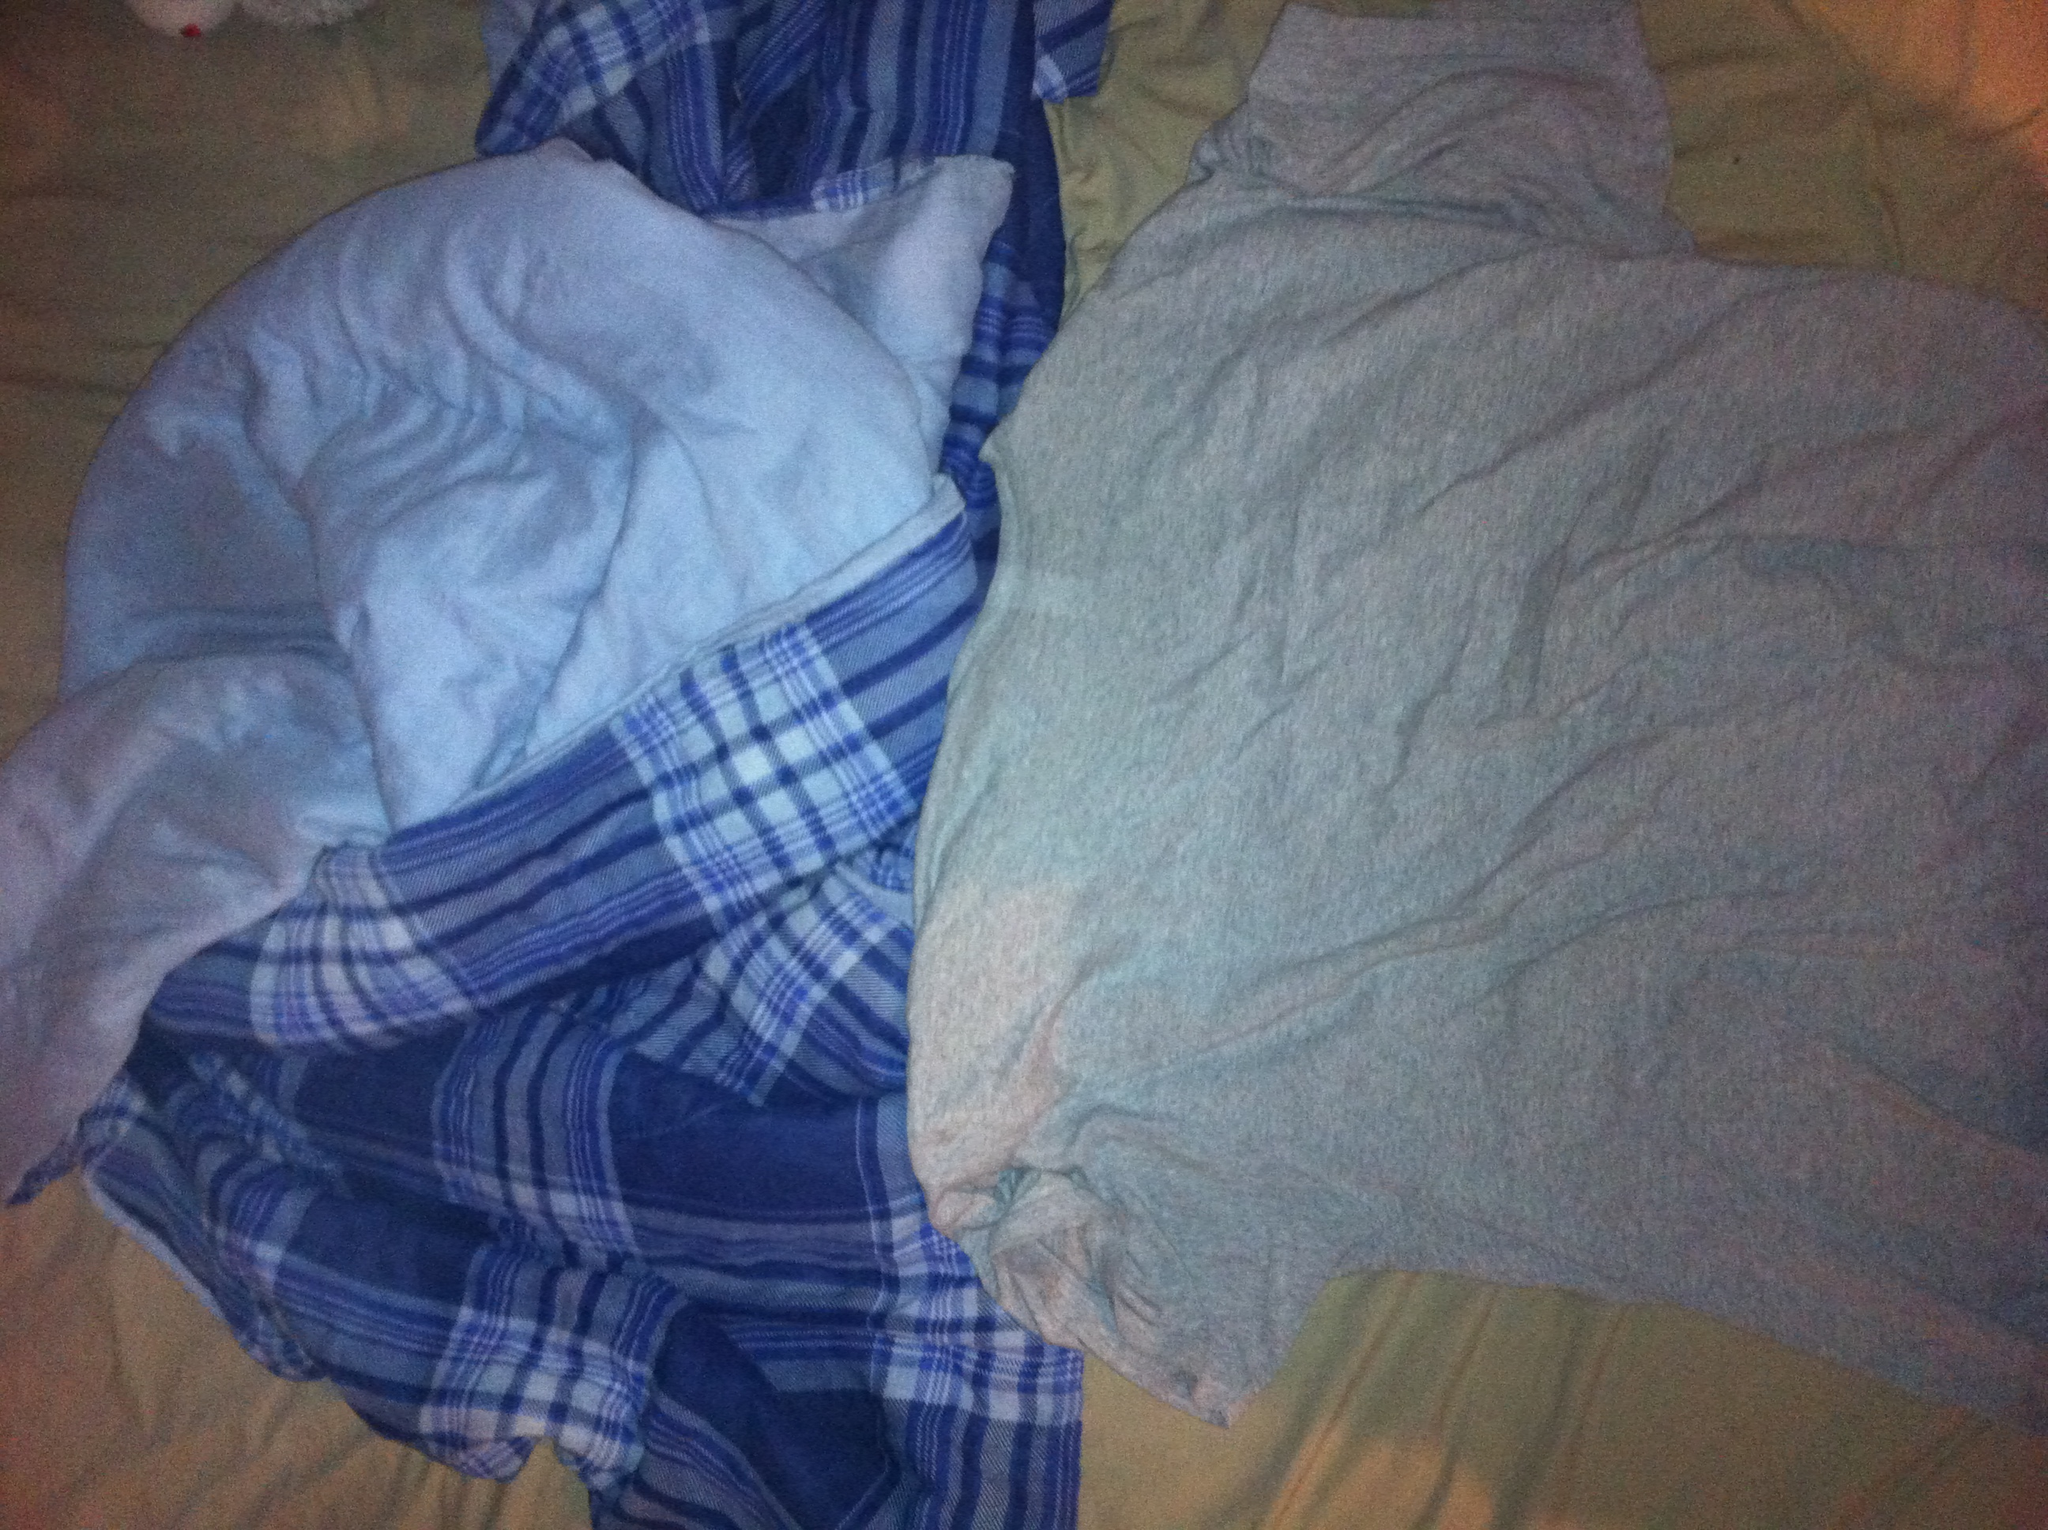Can you describe the fabrics seen in the image? Sure! The image shows two types of fabrics. On the left side, there is a piece of fabric with a blue and white checkered pattern, which looks like it might be a comfortable, soft blanket or some cozy pajama pants. On the right side, there is a plain light grey shirt made from a typical soft cotton material, often worn for casual comfort. Which fabric looks more comfortable? Both fabrics appear to be quite comfortable, but if I had to choose, the checkered blue and white fabric on the left might be more comfortable as it appears to be thicker and cosier. Ideal for wrapping oneself in. 